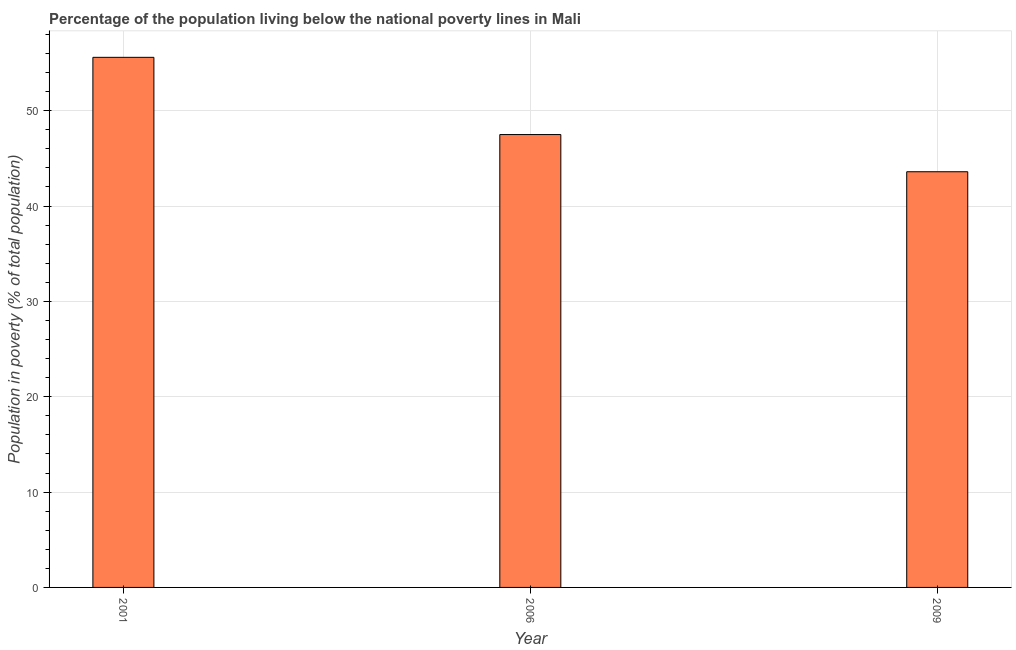What is the title of the graph?
Your answer should be very brief. Percentage of the population living below the national poverty lines in Mali. What is the label or title of the X-axis?
Give a very brief answer. Year. What is the label or title of the Y-axis?
Offer a very short reply. Population in poverty (% of total population). What is the percentage of population living below poverty line in 2006?
Your answer should be compact. 47.5. Across all years, what is the maximum percentage of population living below poverty line?
Give a very brief answer. 55.6. Across all years, what is the minimum percentage of population living below poverty line?
Make the answer very short. 43.6. In which year was the percentage of population living below poverty line maximum?
Your answer should be very brief. 2001. In which year was the percentage of population living below poverty line minimum?
Your response must be concise. 2009. What is the sum of the percentage of population living below poverty line?
Your answer should be very brief. 146.7. What is the average percentage of population living below poverty line per year?
Ensure brevity in your answer.  48.9. What is the median percentage of population living below poverty line?
Keep it short and to the point. 47.5. In how many years, is the percentage of population living below poverty line greater than 4 %?
Provide a short and direct response. 3. Do a majority of the years between 2001 and 2006 (inclusive) have percentage of population living below poverty line greater than 48 %?
Ensure brevity in your answer.  No. What is the ratio of the percentage of population living below poverty line in 2001 to that in 2006?
Offer a terse response. 1.17. Is the percentage of population living below poverty line in 2001 less than that in 2006?
Your response must be concise. No. Is the sum of the percentage of population living below poverty line in 2006 and 2009 greater than the maximum percentage of population living below poverty line across all years?
Make the answer very short. Yes. How many bars are there?
Your answer should be compact. 3. Are the values on the major ticks of Y-axis written in scientific E-notation?
Keep it short and to the point. No. What is the Population in poverty (% of total population) of 2001?
Make the answer very short. 55.6. What is the Population in poverty (% of total population) in 2006?
Your answer should be compact. 47.5. What is the Population in poverty (% of total population) of 2009?
Ensure brevity in your answer.  43.6. What is the difference between the Population in poverty (% of total population) in 2006 and 2009?
Your answer should be compact. 3.9. What is the ratio of the Population in poverty (% of total population) in 2001 to that in 2006?
Make the answer very short. 1.17. What is the ratio of the Population in poverty (% of total population) in 2001 to that in 2009?
Keep it short and to the point. 1.27. What is the ratio of the Population in poverty (% of total population) in 2006 to that in 2009?
Provide a succinct answer. 1.09. 